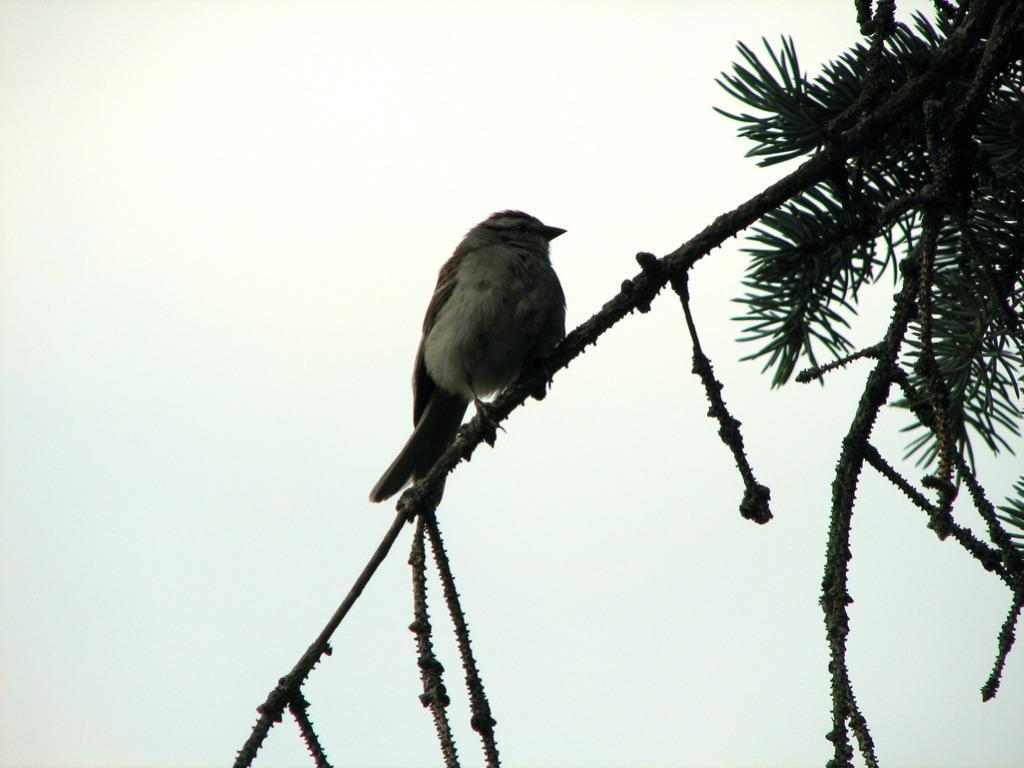What type of animal can be seen in the image? There is a bird in the image. Where is the bird located? The bird is on a branch of a tree. What can be seen in the background of the image? There is sky visible in the background of the image. What is the bird's reaction to the team's performance in the image? There is no team or performance present in the image, so it is not possible to determine the bird's reaction. 